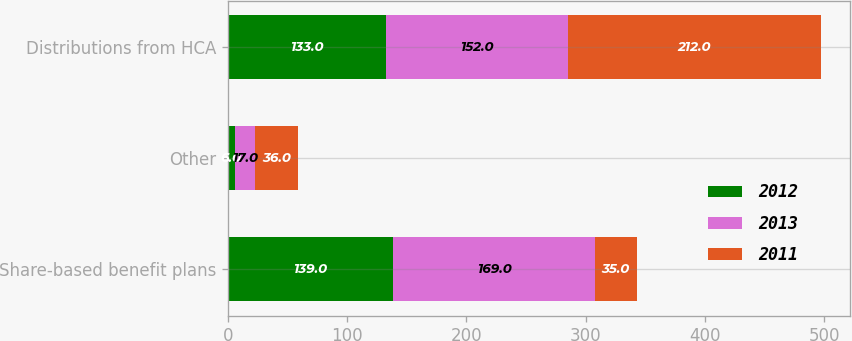Convert chart. <chart><loc_0><loc_0><loc_500><loc_500><stacked_bar_chart><ecel><fcel>Share-based benefit plans<fcel>Other<fcel>Distributions from HCA<nl><fcel>2012<fcel>139<fcel>6<fcel>133<nl><fcel>2013<fcel>169<fcel>17<fcel>152<nl><fcel>2011<fcel>35<fcel>36<fcel>212<nl></chart> 